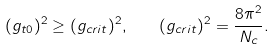<formula> <loc_0><loc_0><loc_500><loc_500>( g _ { t 0 } ) ^ { 2 } \geq ( g _ { c r i t } ) ^ { 2 } , \quad ( g _ { c r i t } ) ^ { 2 } = \frac { 8 \pi ^ { 2 } } { N _ { c } } .</formula> 